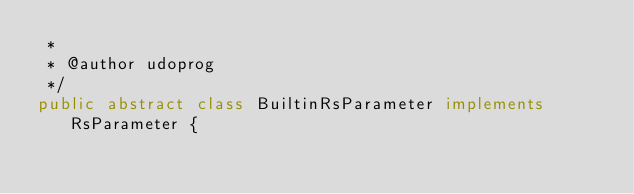<code> <loc_0><loc_0><loc_500><loc_500><_Java_> *
 * @author udoprog
 */
public abstract class BuiltinRsParameter implements RsParameter {</code> 